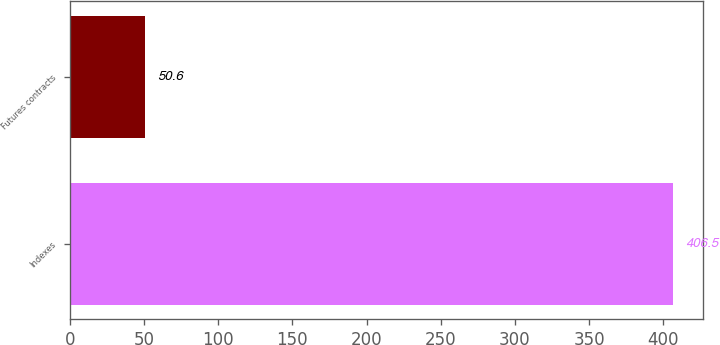Convert chart to OTSL. <chart><loc_0><loc_0><loc_500><loc_500><bar_chart><fcel>Indexes<fcel>Futures contracts<nl><fcel>406.5<fcel>50.6<nl></chart> 